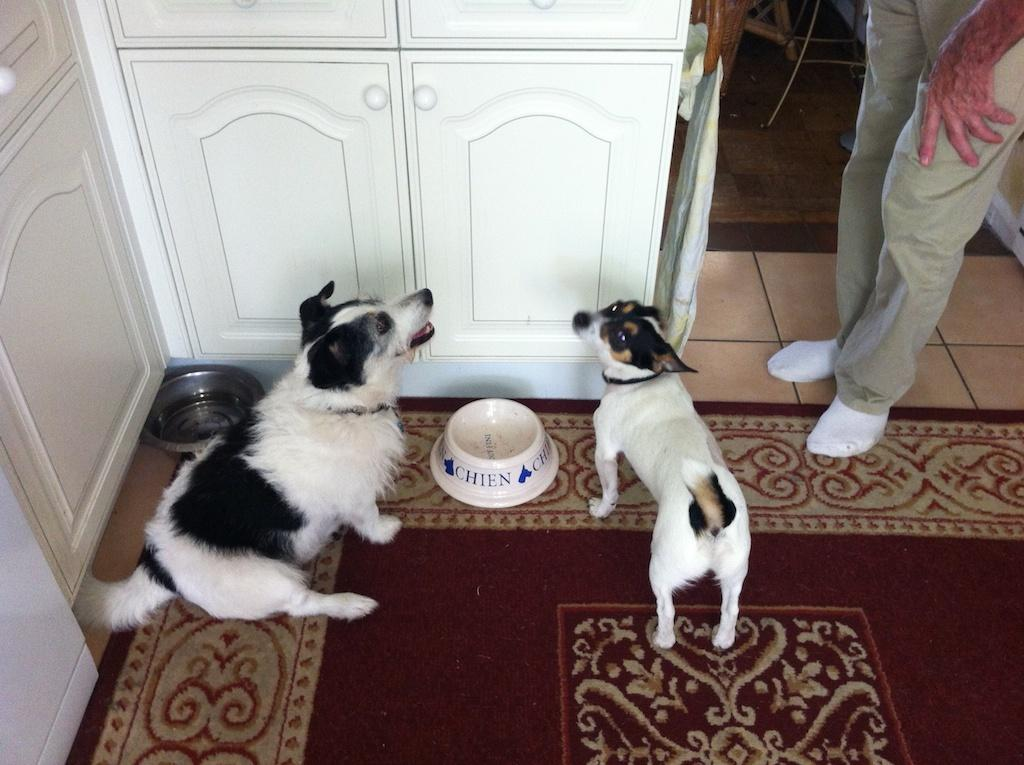Who is present in the image? There is a man in the image. What animals are in the image? There are two dogs in the image. What are the dogs interacting with in the image? The dogs are interacting with bowls in front of them. What type of furniture is visible in the image? There are cupboards in the image. How many beds can be seen in the image? There are no beds visible in the image. What type of bead is being used as a decoration in the image? There is no bead present in the image. 